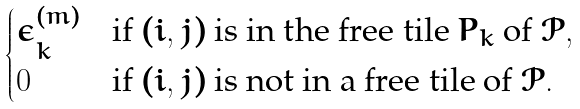<formula> <loc_0><loc_0><loc_500><loc_500>\begin{cases} \epsilon ^ { ( m ) } _ { k } & \text {if $(i,j)$ is in the free tile $P_{k}$ of $\mathscr{P}$} , \\ 0 & \text {if $(i,j)$ is not in a free tile of $\mathscr{P}$} . \end{cases}</formula> 